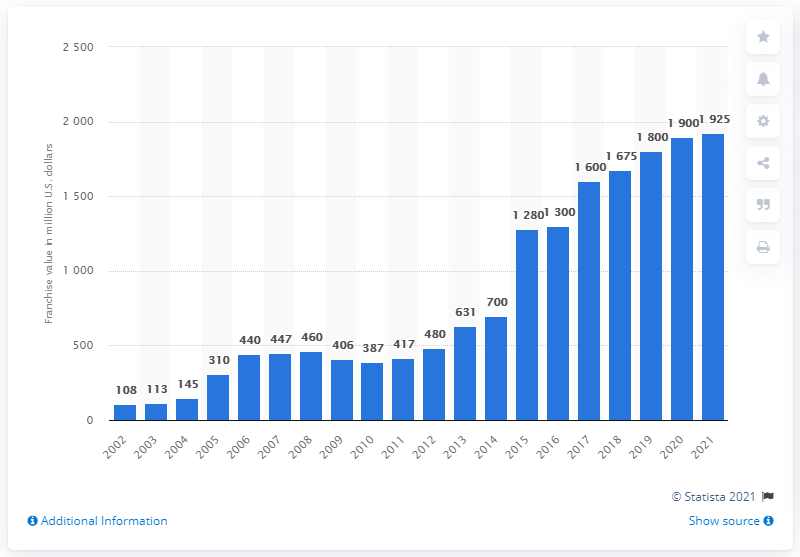List a handful of essential elements in this visual. The estimated value of the Washington Nationals in 2021 was approximately 1925. 